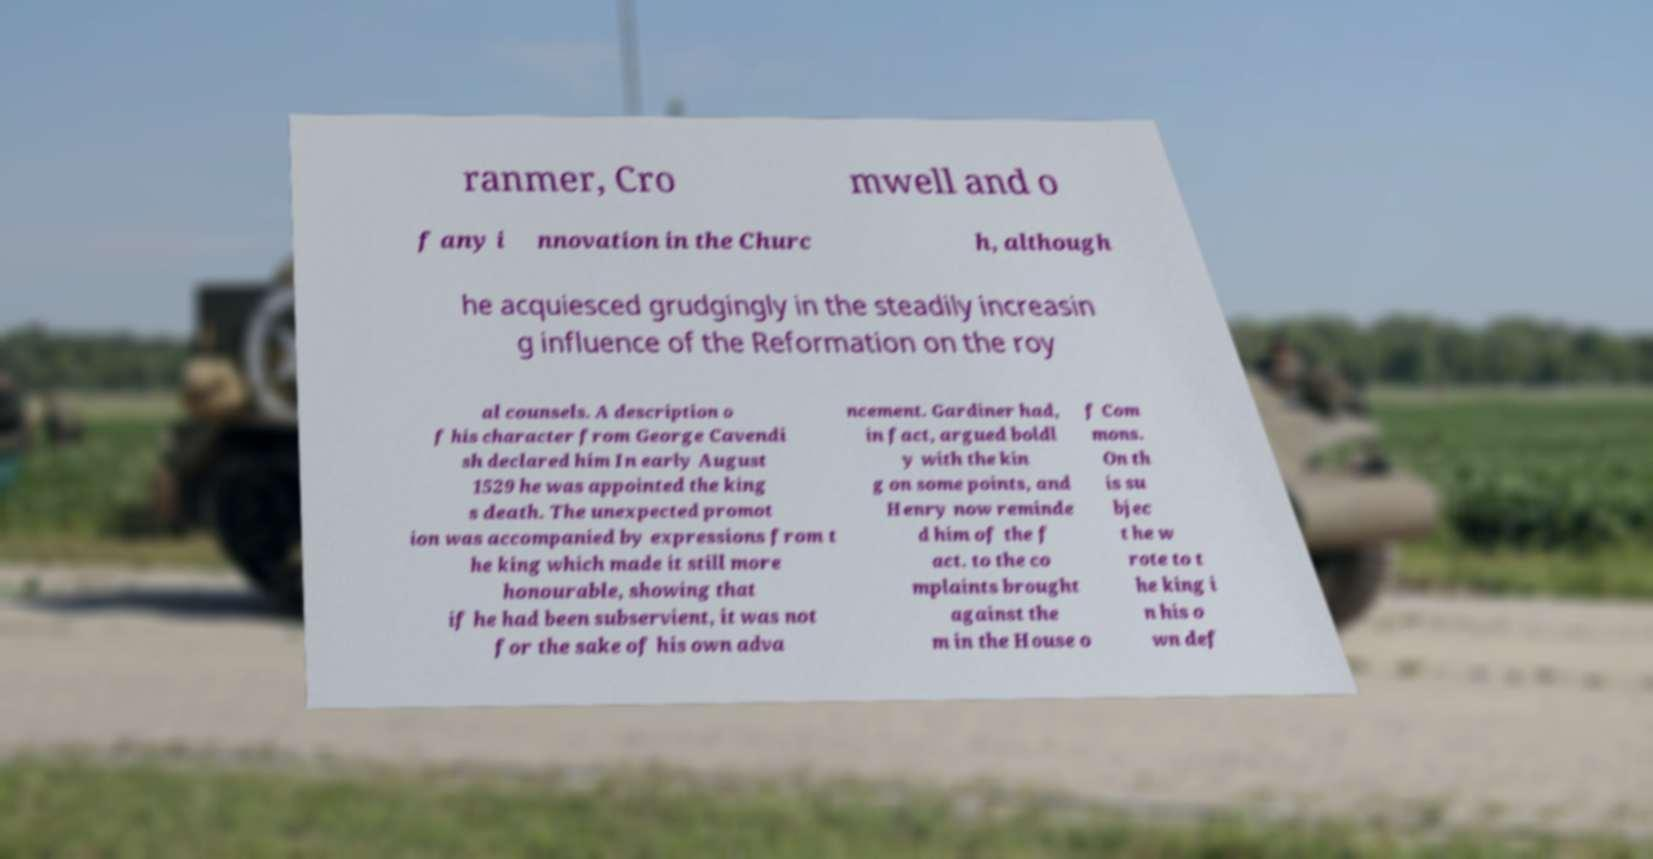I need the written content from this picture converted into text. Can you do that? ranmer, Cro mwell and o f any i nnovation in the Churc h, although he acquiesced grudgingly in the steadily increasin g influence of the Reformation on the roy al counsels. A description o f his character from George Cavendi sh declared him In early August 1529 he was appointed the king s death. The unexpected promot ion was accompanied by expressions from t he king which made it still more honourable, showing that if he had been subservient, it was not for the sake of his own adva ncement. Gardiner had, in fact, argued boldl y with the kin g on some points, and Henry now reminde d him of the f act. to the co mplaints brought against the m in the House o f Com mons. On th is su bjec t he w rote to t he king i n his o wn def 